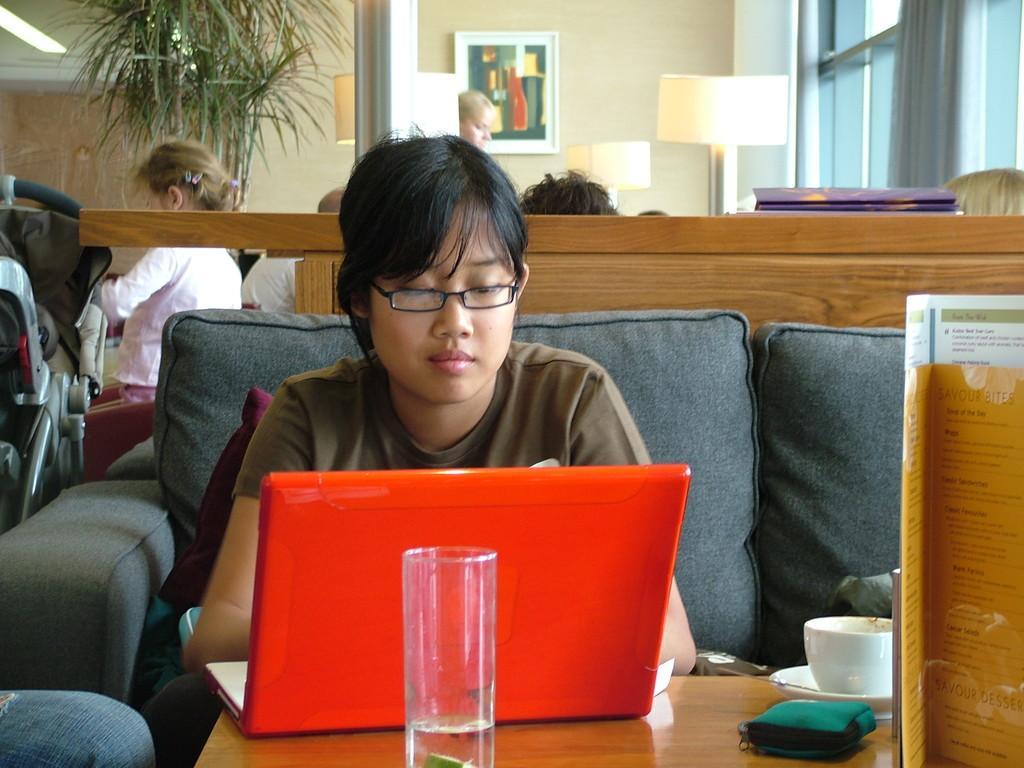Can you describe this image briefly? a person is sitting on the sofa operation red color laptop. in the front there is a glass, a cup and saucer. behind her there are other people, tree and a photo frame 